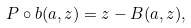<formula> <loc_0><loc_0><loc_500><loc_500>P \circ { b } ( a , z ) = z - B ( a , z ) ,</formula> 